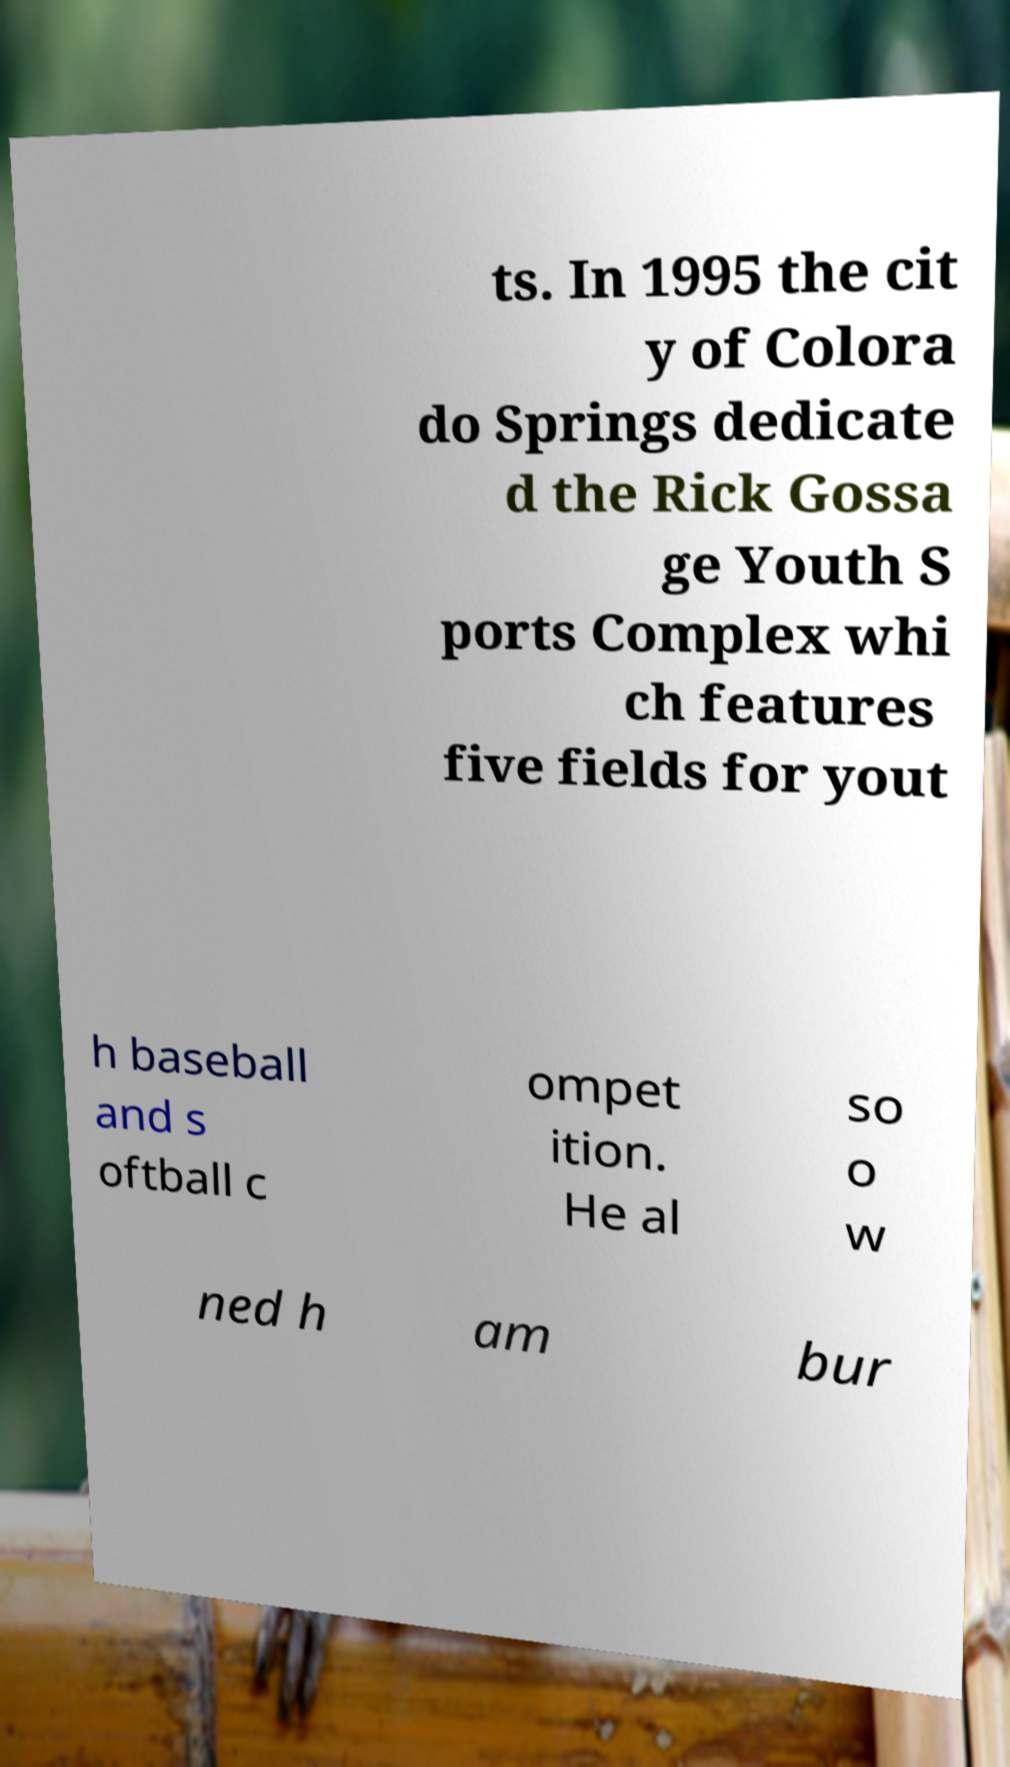Please identify and transcribe the text found in this image. ts. In 1995 the cit y of Colora do Springs dedicate d the Rick Gossa ge Youth S ports Complex whi ch features five fields for yout h baseball and s oftball c ompet ition. He al so o w ned h am bur 